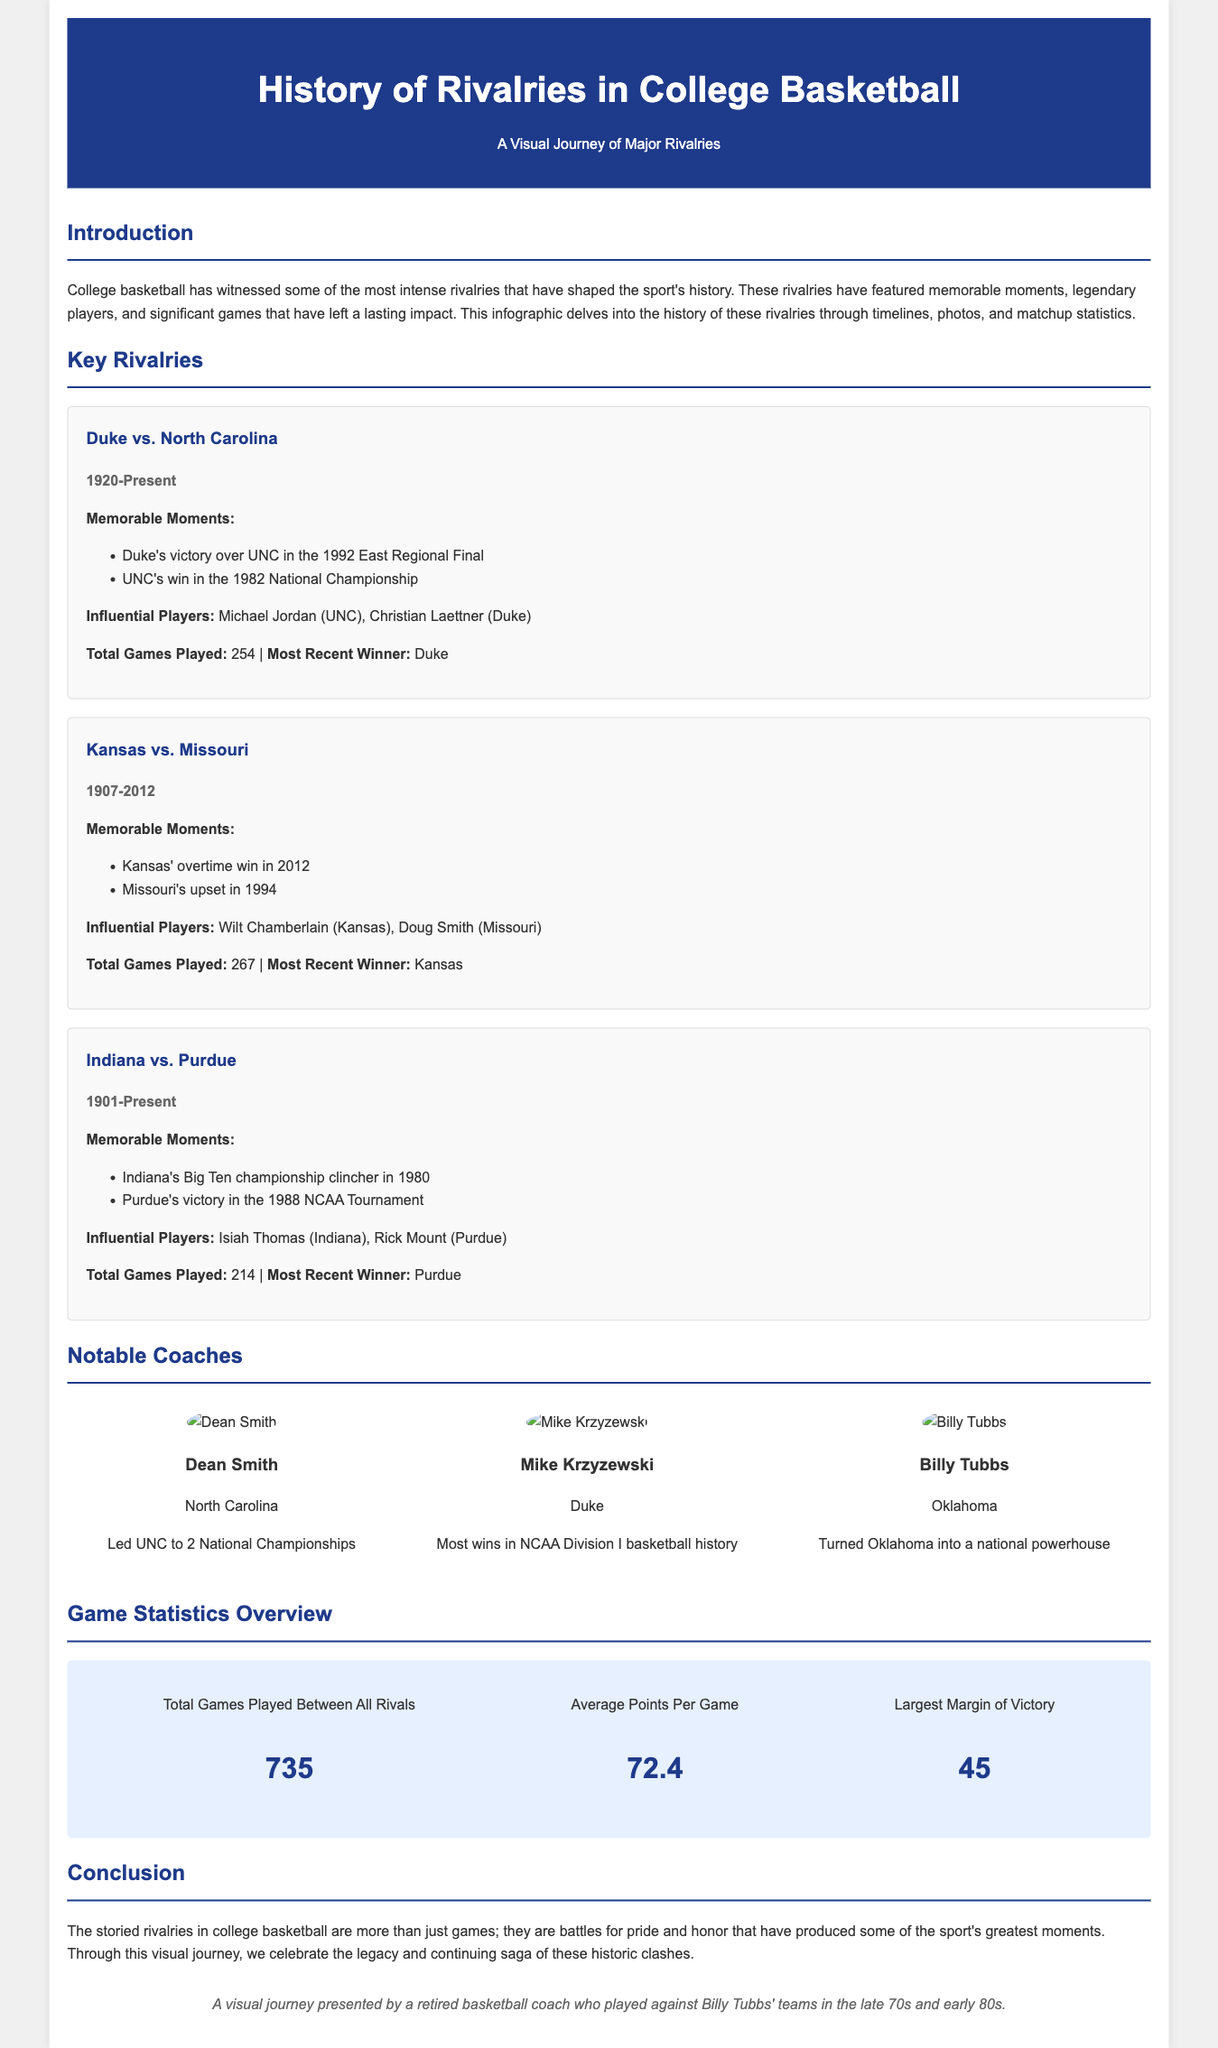What is the rivalry covered since 1920? The document mentions the Duke vs. North Carolina rivalry, which started in 1920 and continues to the present.
Answer: Duke vs. North Carolina Who won the most recent Duke vs. North Carolina game? According to the infographic, Duke is noted as the most recent winner of the rivalry.
Answer: Duke How many total games have been played between all rivalries? The infographic states the total number of games played between all rivalries is 735.
Answer: 735 Which influential player is associated with Purdue? The document lists Rick Mount as the influential player from Purdue in the rivalry section.
Answer: Rick Mount What year did Kansas and Missouri's rivalry end? Kansas vs. Missouri rivalry is noted to have ended in 2012, as per the timeline in the document.
Answer: 2012 What is the largest margin of victory mentioned in the statistics overview? The largest margin of victory provided in the document is 45 points.
Answer: 45 How many championships did Dean Smith lead North Carolina to? The infographic notes that Dean Smith led North Carolina to 2 National Championships.
Answer: 2 What is the average points per game recorded in the overview? The average points per game mentioned in the infographic is 72.4.
Answer: 72.4 Which team did Billy Tubbs coach? The document identifies Oklahoma as the team coached by Billy Tubbs.
Answer: Oklahoma 